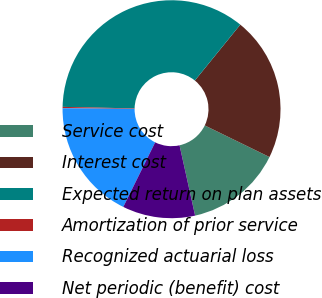<chart> <loc_0><loc_0><loc_500><loc_500><pie_chart><fcel>Service cost<fcel>Interest cost<fcel>Expected return on plan assets<fcel>Amortization of prior service<fcel>Recognized actuarial loss<fcel>Net periodic (benefit) cost<nl><fcel>14.3%<fcel>21.37%<fcel>35.52%<fcel>0.2%<fcel>17.84%<fcel>10.77%<nl></chart> 